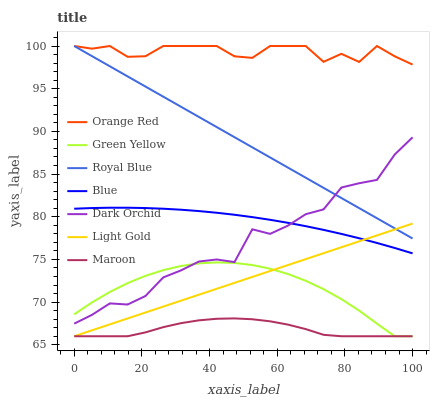Does Maroon have the minimum area under the curve?
Answer yes or no. Yes. Does Orange Red have the maximum area under the curve?
Answer yes or no. Yes. Does Dark Orchid have the minimum area under the curve?
Answer yes or no. No. Does Dark Orchid have the maximum area under the curve?
Answer yes or no. No. Is Royal Blue the smoothest?
Answer yes or no. Yes. Is Dark Orchid the roughest?
Answer yes or no. Yes. Is Dark Orchid the smoothest?
Answer yes or no. No. Is Royal Blue the roughest?
Answer yes or no. No. Does Maroon have the lowest value?
Answer yes or no. Yes. Does Dark Orchid have the lowest value?
Answer yes or no. No. Does Orange Red have the highest value?
Answer yes or no. Yes. Does Dark Orchid have the highest value?
Answer yes or no. No. Is Light Gold less than Orange Red?
Answer yes or no. Yes. Is Orange Red greater than Light Gold?
Answer yes or no. Yes. Does Blue intersect Light Gold?
Answer yes or no. Yes. Is Blue less than Light Gold?
Answer yes or no. No. Is Blue greater than Light Gold?
Answer yes or no. No. Does Light Gold intersect Orange Red?
Answer yes or no. No. 